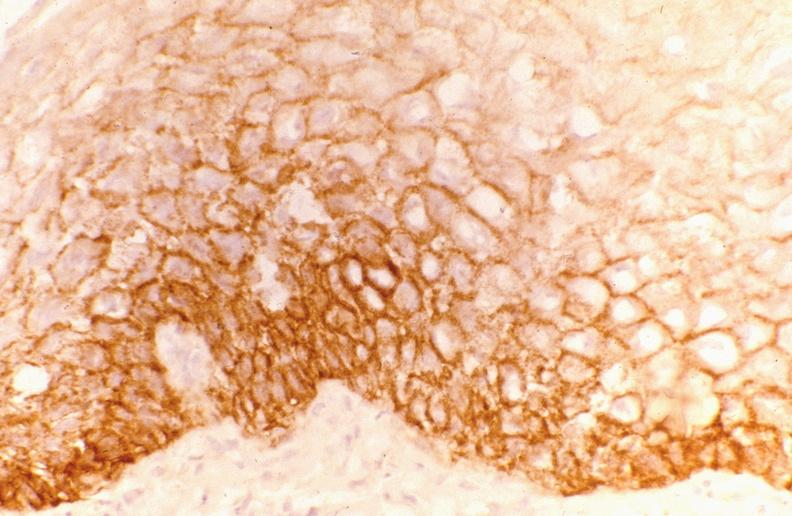what does this image show?
Answer the question using a single word or phrase. Leukoplakia 